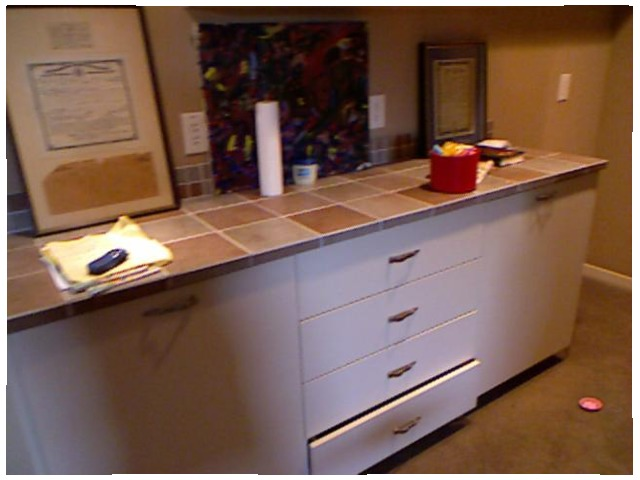<image>
Can you confirm if the table is behind the box? No. The table is not behind the box. From this viewpoint, the table appears to be positioned elsewhere in the scene. Where is the picture in relation to the drawer? Is it above the drawer? No. The picture is not positioned above the drawer. The vertical arrangement shows a different relationship. 